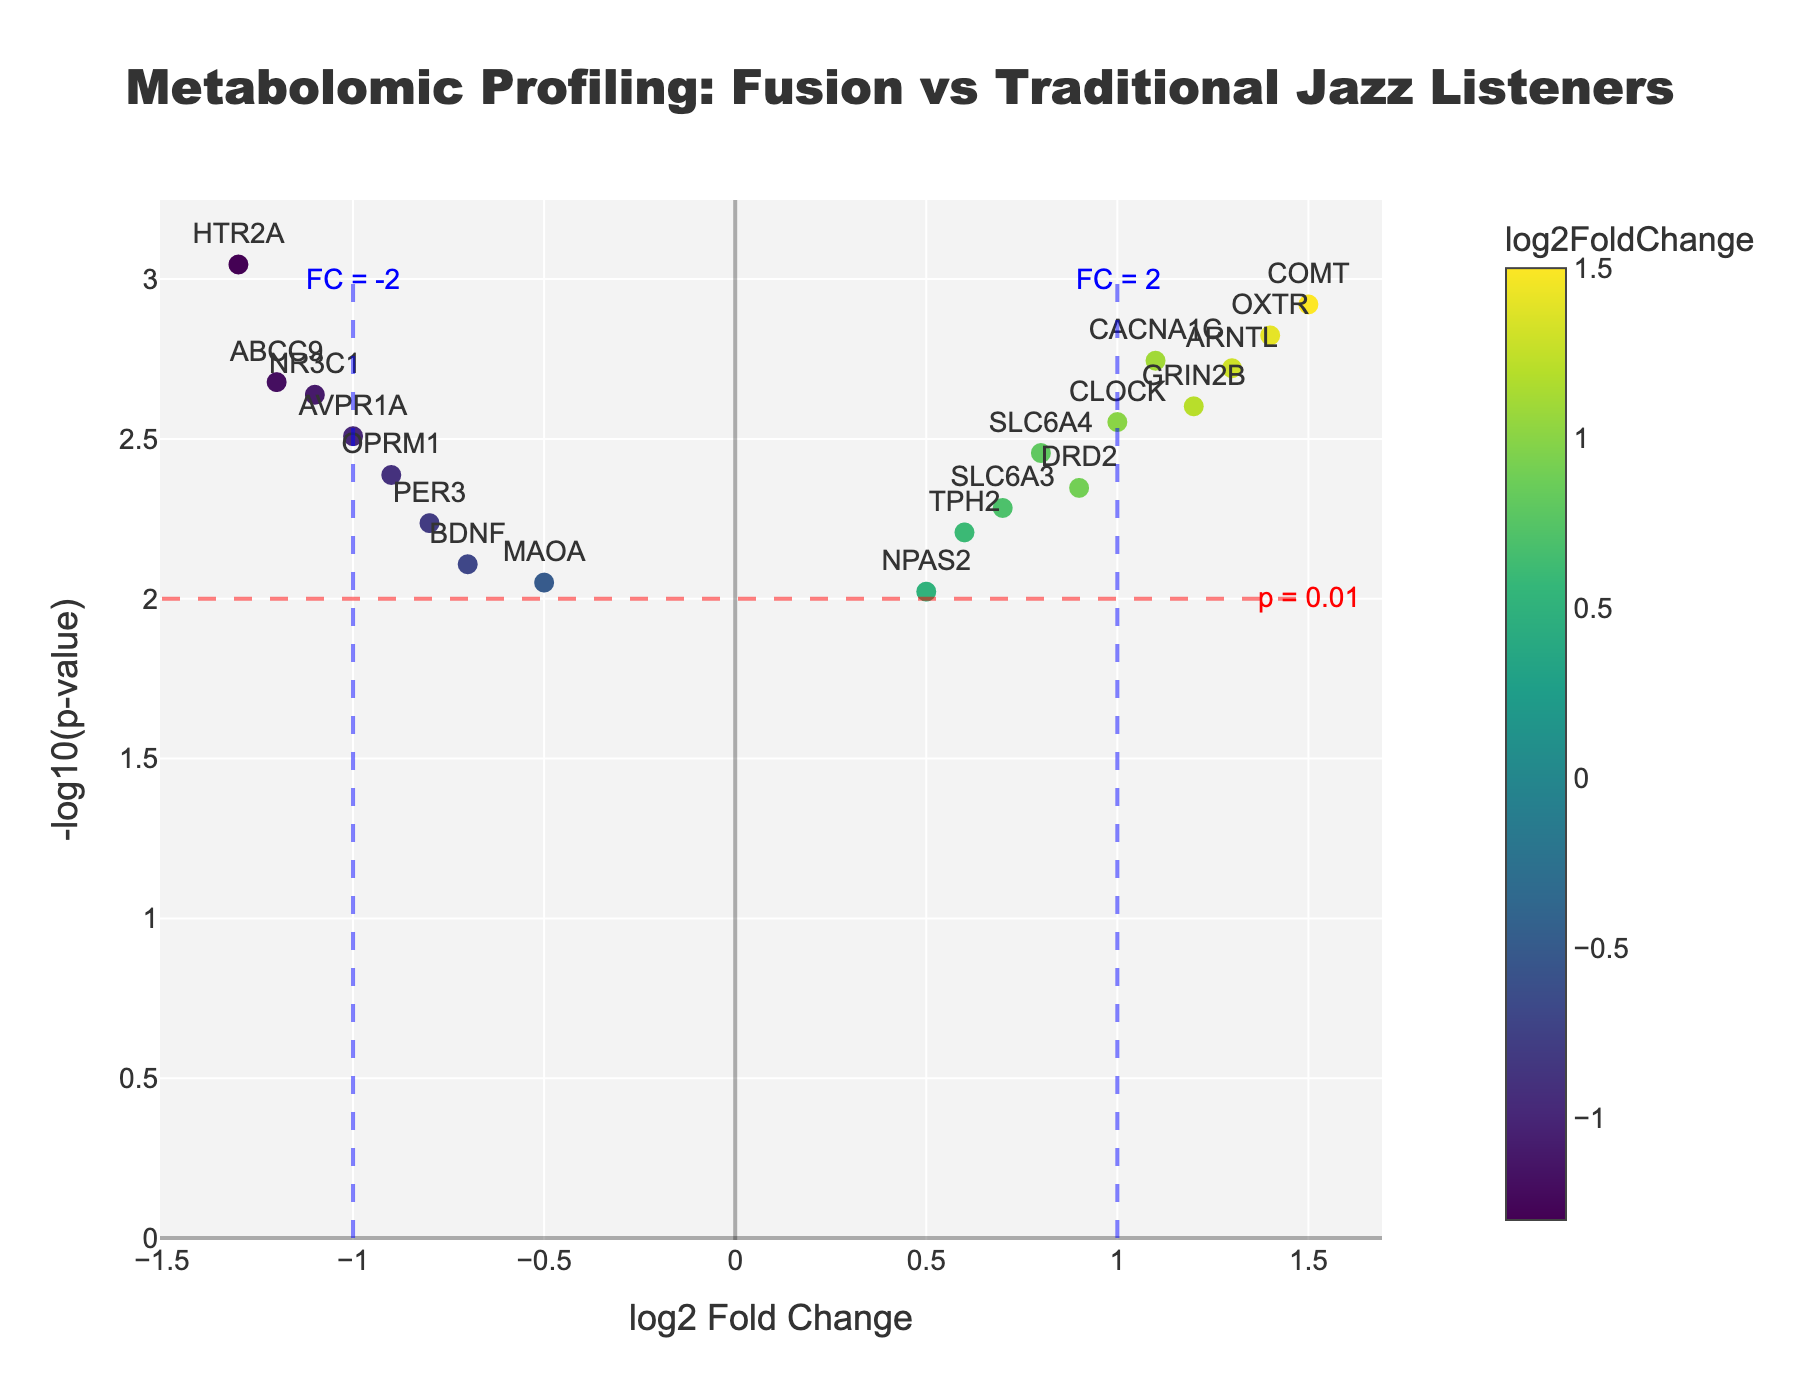What is the title of the plot? The title is found at the top of the plot and it reads "Metabolomic Profiling: Fusion vs Traditional Jazz Listeners".
Answer: Metabolomic Profiling: Fusion vs Traditional Jazz Listeners Which axis represents the log2 Fold Change? The x-axis represents the log2 Fold Change, as indicated by the label "log2 Fold Change" on this axis.
Answer: x-axis How many genes have a negative log2 Fold Change? By counting the data points on the left side of the y-axis (negative x-axis values), we can see eight genes with a negative log2 Fold Change.
Answer: Eight What color scale is used for the data points, and what does it represent? The color scale used is 'Viridis' which transitions from dark purple to yellow. It represents the different values of log2 Fold Change, with different colors indicating different fold changes.
Answer: Viridis Which gene has the highest -log10(p-value)? The data point at the top of the plot corresponds to the highest -log10(p-value). The gene is HTR2A.
Answer: HTR2A Which gene has the largest positive log2 Fold Change? By looking at the data point furthest to the right on the x-axis, we can see that COMT has the largest positive log2 Fold Change of 1.5.
Answer: COMT What is the significance threshold for -log10(p-value), and how is it indicated in the plot? The significance threshold for -log10(p-value) is 2, and it is indicated by a dashed red line across the plot.
Answer: 2 How many genes have both a significant p-value and a log2 Fold Change greater than 1? Genes with a significant p-value will be above the red dashed line, and those with log2 Fold Change greater than 1 will be to the right of the blue dashed line at x=1. This results in the genes COMT, CACNA1C, GRIN2B, OXTR, and ARNTL.
Answer: Five Compare the log2 Fold Change and -log10(p-value) for SLC6A4 and PER3. Which gene is more significant? To determine which gene is more significant, look at the -log10(p-value) value. SLC6A4 has a -log10(p-value) of approximately 2.45, while PER3 has a -log10(p-value) of approximately 2.24. SLC6A4 is more significant.
Answer: SLC6A4 What is the log2 Fold Change range for the genes in the plot? The range can be determined by identifying the minimum and maximum log2 Fold Change values. The minimum log2 Fold Change is approximately -1.3, and the maximum is 1.5. Therefore, the range is from -1.3 to 1.5.
Answer: -1.3 to 1.5 